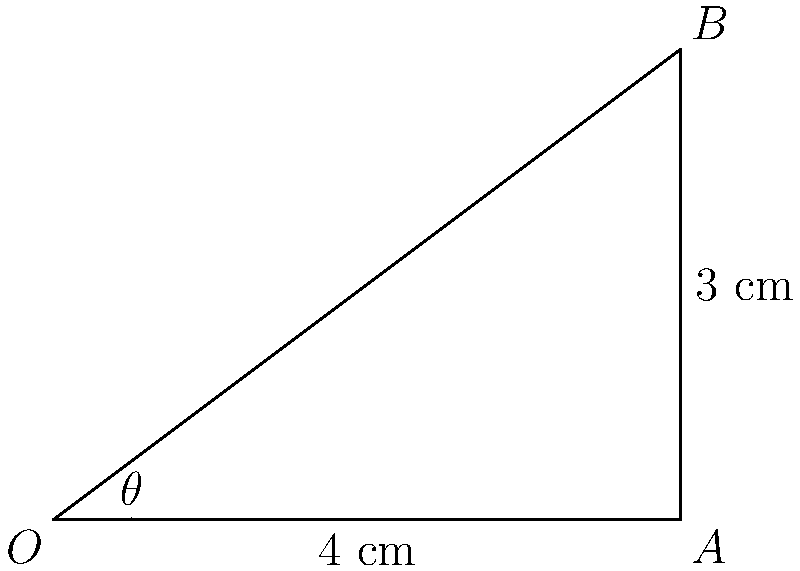As a dental blogger reviewing dental drills, you're analyzing the optimal angle for a new drill design. The drill's tip forms a right triangle with the tooth surface, where the base of the triangle is 4 cm and the height is 3 cm. What is the optimal angle $\theta$ (in degrees) between the drill and the tooth surface for maximum efficiency? To find the optimal angle $\theta$, we need to use trigonometry in the right triangle formed by the drill and tooth surface.

Step 1: Identify the sides of the right triangle
- The adjacent side (base) is 4 cm
- The opposite side (height) is 3 cm
- The hypotenuse is the length of the drill

Step 2: Determine which trigonometric function to use
We want to find the angle, and we know the opposite and adjacent sides. This calls for the tangent function.

Step 3: Set up the tangent equation
$\tan(\theta) = \frac{\text{opposite}}{\text{adjacent}} = \frac{3}{4}$

Step 4: Solve for $\theta$ using the inverse tangent (arctangent) function
$\theta = \tan^{-1}(\frac{3}{4})$

Step 5: Calculate the result
Using a calculator or computer:
$\theta \approx 36.87°$

Step 6: Round to the nearest degree
$\theta \approx 37°$

Therefore, the optimal angle for the dental drill is approximately 37 degrees from the tooth surface.
Answer: $37°$ 